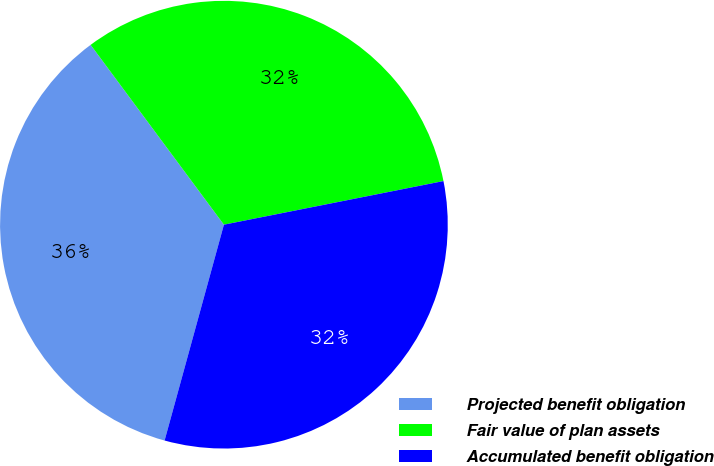Convert chart. <chart><loc_0><loc_0><loc_500><loc_500><pie_chart><fcel>Projected benefit obligation<fcel>Fair value of plan assets<fcel>Accumulated benefit obligation<nl><fcel>35.58%<fcel>32.03%<fcel>32.39%<nl></chart> 